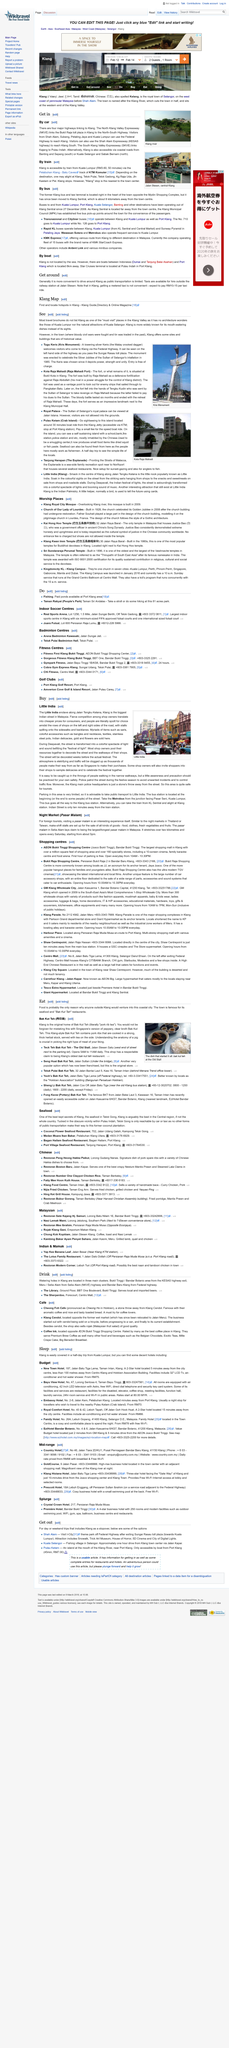Outline some significant characteristics in this image. The location of the first establishment of Bak Kut Teh is Klang, and it is the original home of this dish. Two establishments, Tack Teh Bak Kut Teh and Seng Huat Bak Kut Teh, specialize in selling Bak Kut Teh, a delicious dish made from herbs, spices, and pork ribs. On Deepavali, the streets are transformed into a colorful spectacle of light and sound as a festival is celebrated. Bak Kut Teh is a type of soup that originated in Singapore and Malaysia, and its literal translation is "pork rib tea. The photo was taken in Little India in Malaysia. 